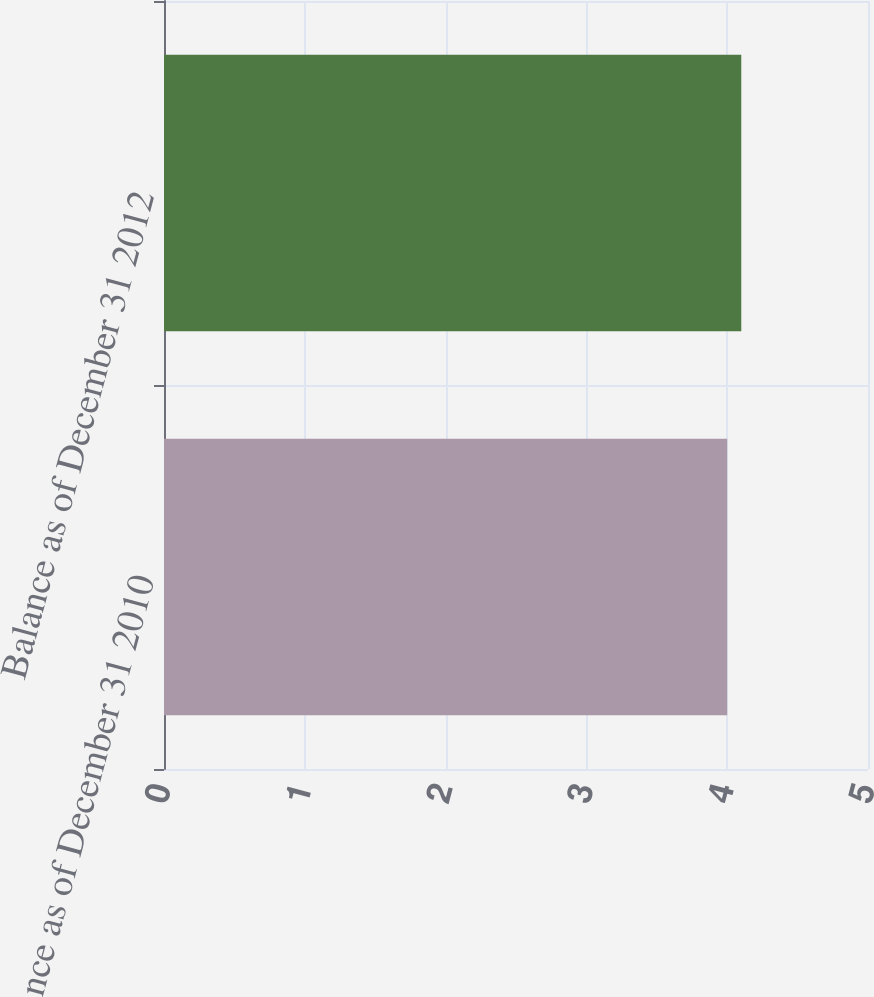Convert chart. <chart><loc_0><loc_0><loc_500><loc_500><bar_chart><fcel>Balance as of December 31 2010<fcel>Balance as of December 31 2012<nl><fcel>4<fcel>4.1<nl></chart> 